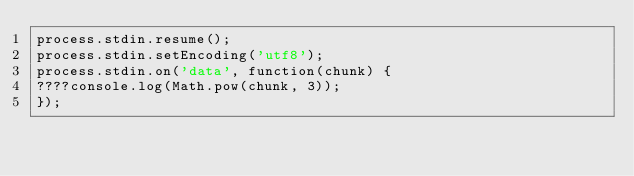<code> <loc_0><loc_0><loc_500><loc_500><_JavaScript_>process.stdin.resume();
process.stdin.setEncoding('utf8');
process.stdin.on('data', function(chunk) {
????console.log(Math.pow(chunk, 3));
});</code> 